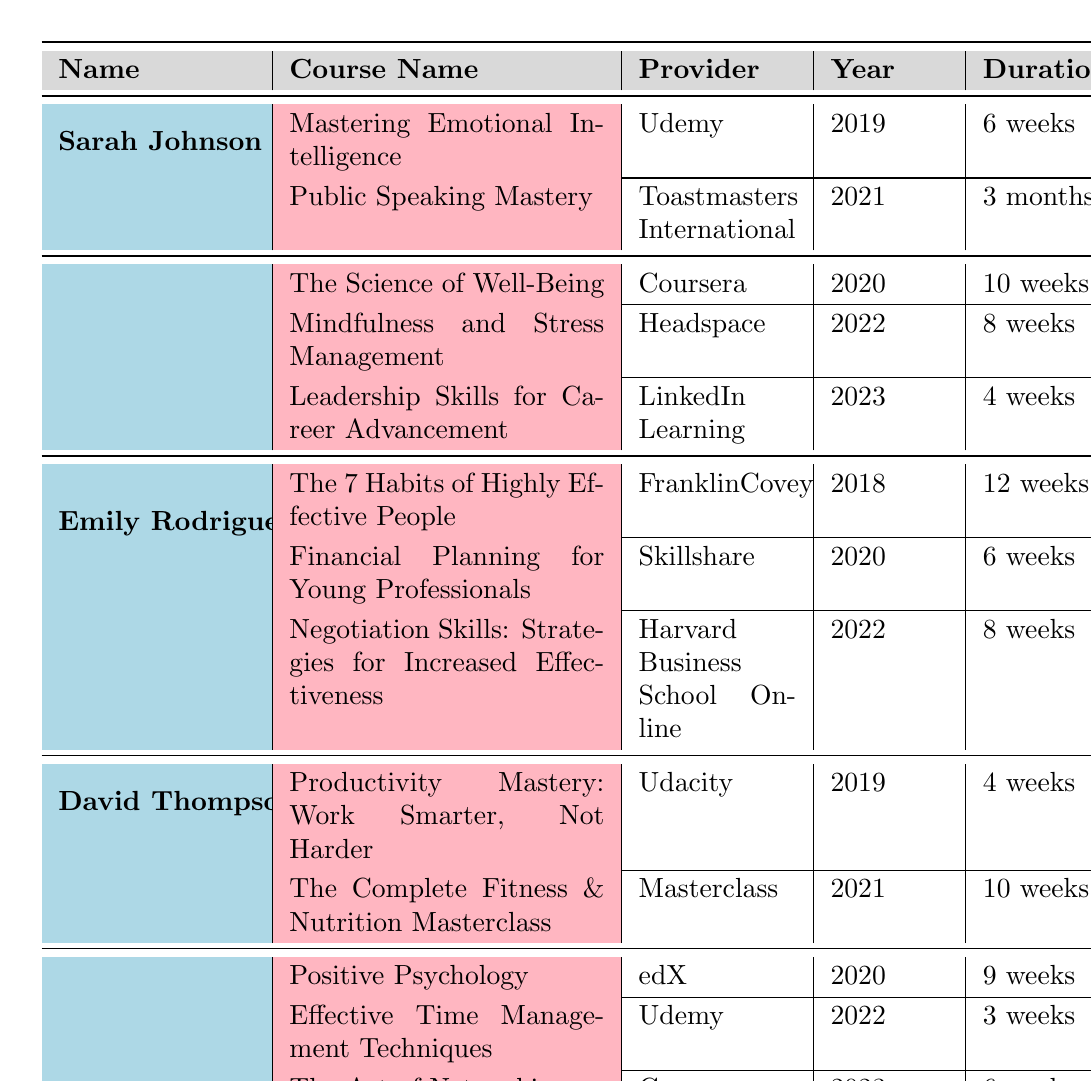What course did Michael Chen take in 2020? The table lists the courses taken by each classmate. For Michael Chen, in 2020 he took "The Science of Well-Being."
Answer: The Science of Well-Being How many courses did Sarah Johnson take? By looking at the courses listed under Sarah Johnson's name, there are two courses: "Mastering Emotional Intelligence" and "Public Speaking Mastery."
Answer: 2 Who provided the course "Negotiation Skills: Strategies for Increased Effectiveness"? The table shows that "Negotiation Skills: Strategies for Increased Effectiveness" was provided by Harvard Business School Online under Emily Rodriguez's courses.
Answer: Harvard Business School Online In what year did Jessica Lee take a course related to time management? To find this, we look at Jessica Lee's courses. The course "Effective Time Management Techniques" was taken in 2022.
Answer: 2022 Which classmate took the most courses and how many did they take? Reviewing the table, we see that Michael Chen and Emily Rodriguez each took three courses, which is the highest number among classmates.
Answer: Michael Chen and Emily Rodriguez; 3 courses Is "Public Speaking Mastery" a course offered by Udemy? Looking at the provided information, "Public Speaking Mastery" is associated with Toastmasters International, not Udemy.
Answer: No What is the average duration of the courses taken by David Thompson? David Thompson took two courses: "Productivity Mastery: Work Smarter, Not Harder" (4 weeks) and "The Complete Fitness & Nutrition Masterclass" (10 weeks). The average duration is (4 + 10) / 2 = 7 weeks.
Answer: 7 weeks Which provider has offered the most courses among the classmates? By examining all courses, Udemy has provided courses for both Sarah Johnson and Jessica Lee (two courses total), whereas other providers have less representation.
Answer: Udemy Did any classmate take a course in 2019? If so, who? Yes, both Sarah Johnson and David Thompson took courses in 2019, according to the table.
Answer: Yes, Sarah Johnson and David Thompson What is the total number of weeks for all the courses taken by Emily Rodriguez? Emily Rodriguez's courses are "The 7 Habits of Highly Effective People" (12 weeks) + "Financial Planning for Young Professionals" (6 weeks) + "Negotiation Skills: Strategies for Increased Effectiveness" (8 weeks), totaling 26 weeks.
Answer: 26 weeks 